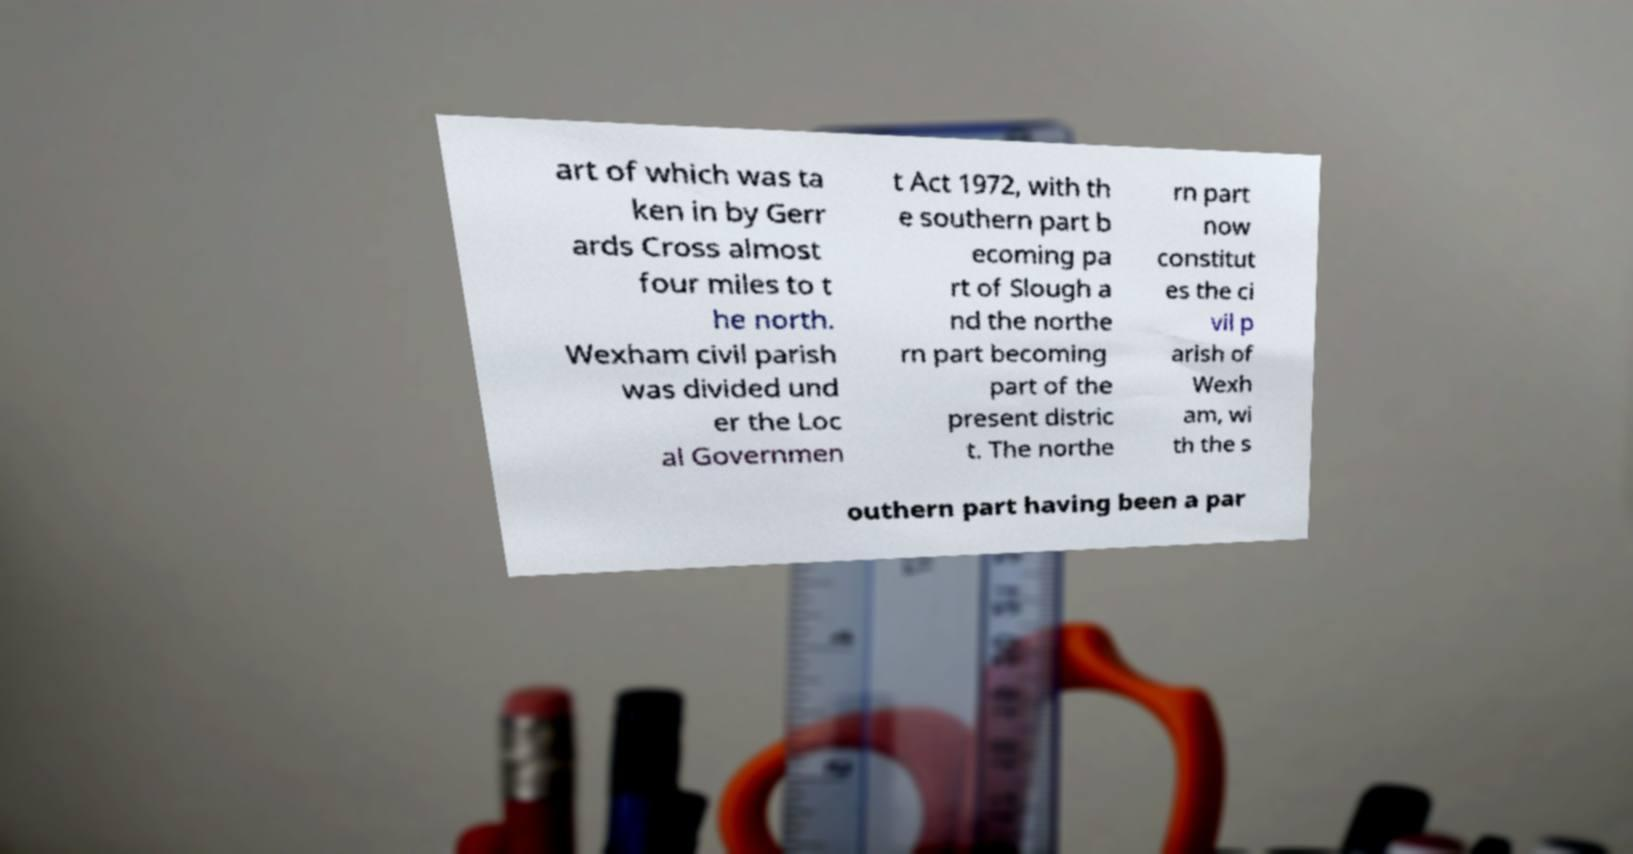Please identify and transcribe the text found in this image. art of which was ta ken in by Gerr ards Cross almost four miles to t he north. Wexham civil parish was divided und er the Loc al Governmen t Act 1972, with th e southern part b ecoming pa rt of Slough a nd the northe rn part becoming part of the present distric t. The northe rn part now constitut es the ci vil p arish of Wexh am, wi th the s outhern part having been a par 